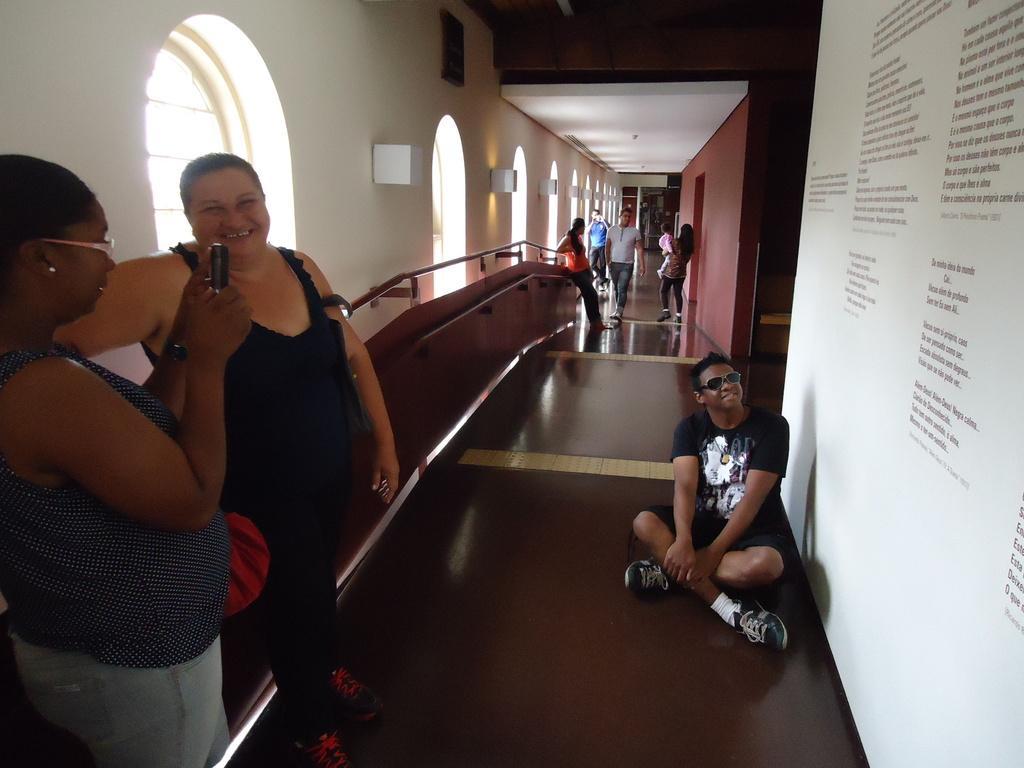How would you summarize this image in a sentence or two? In this image we can see a white board. There are few people standing. A lady is holding an object at the left side of the image. There is a window in the image. 